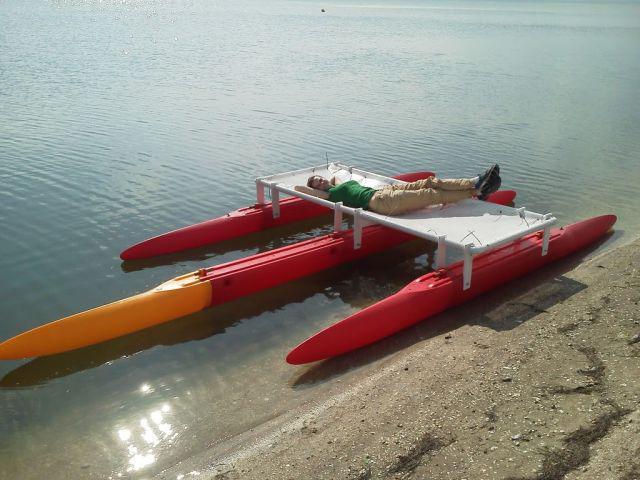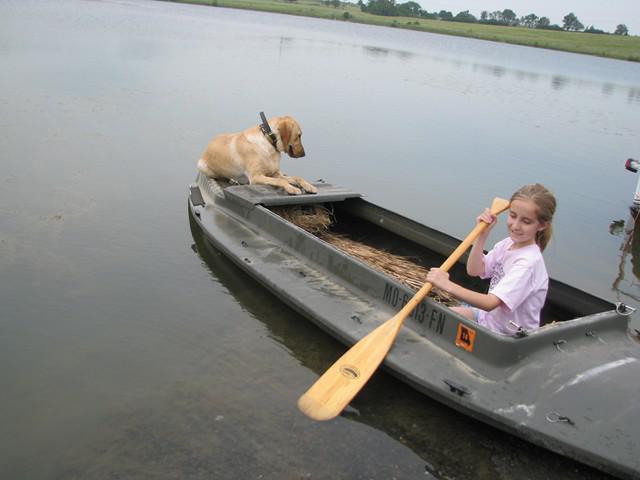The first image is the image on the left, the second image is the image on the right. Given the left and right images, does the statement "An image shows one watercraft made of three floating red parts joined on top by a rectangular shape." hold true? Answer yes or no. Yes. 